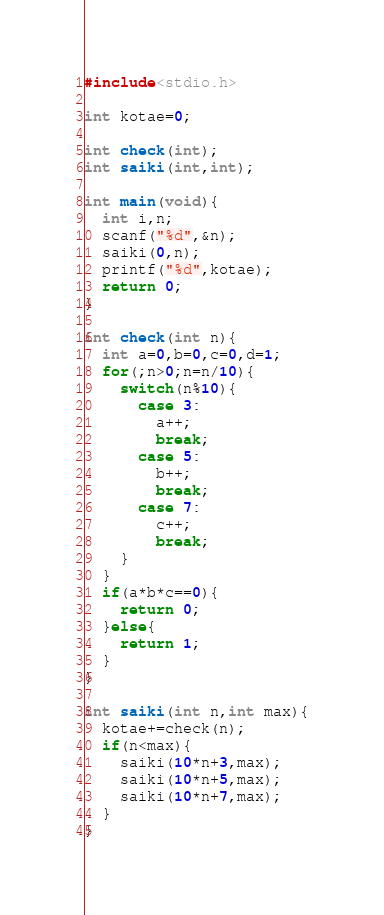<code> <loc_0><loc_0><loc_500><loc_500><_C_>#include<stdio.h>

int kotae=0;

int check(int);
int saiki(int,int);

int main(void){
  int i,n;
  scanf("%d",&n);
  saiki(0,n);
  printf("%d",kotae);
  return 0;
}

int check(int n){
  int a=0,b=0,c=0,d=1;
  for(;n>0;n=n/10){
    switch(n%10){
      case 3:
        a++;
        break;
      case 5:
        b++;
        break;
      case 7:
        c++;
        break;
    }
  }
  if(a*b*c==0){
    return 0;
  }else{
    return 1;
  }
}

int saiki(int n,int max){
  kotae+=check(n);
  if(n<max){
    saiki(10*n+3,max);
    saiki(10*n+5,max);
    saiki(10*n+7,max);
  }
}
</code> 